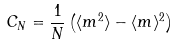Convert formula to latex. <formula><loc_0><loc_0><loc_500><loc_500>C _ { N } = \frac { 1 } { N } \left ( \langle m ^ { 2 } \rangle - \langle m \rangle ^ { 2 } \right )</formula> 